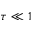Convert formula to latex. <formula><loc_0><loc_0><loc_500><loc_500>\tau \ll 1</formula> 